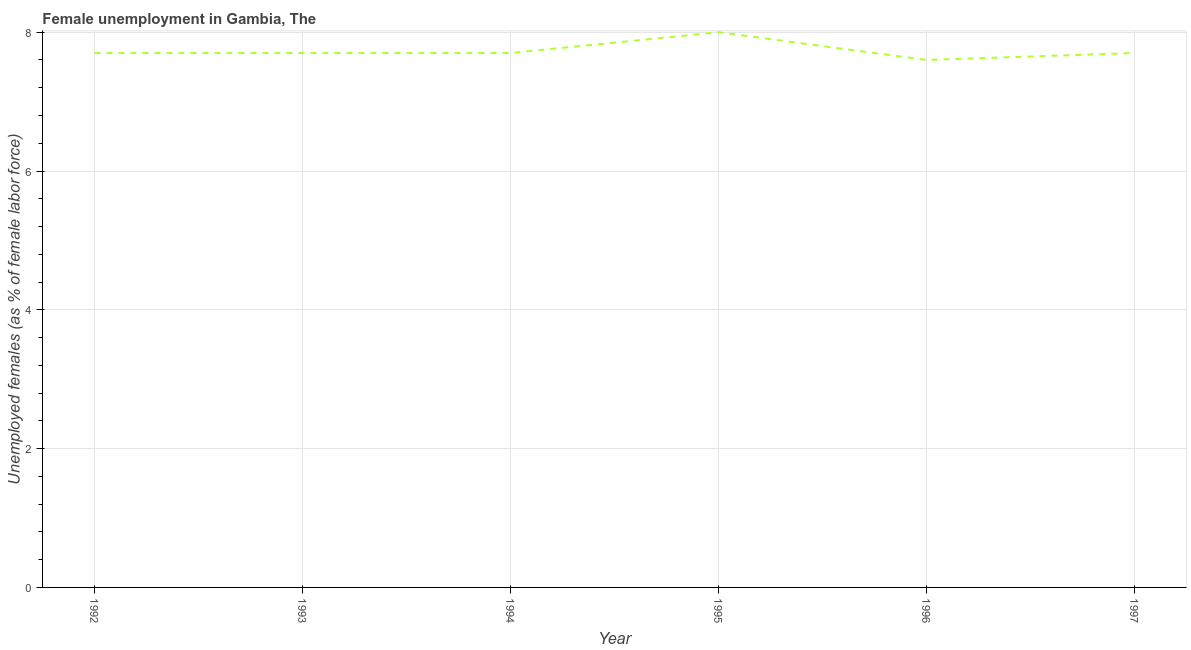What is the unemployed females population in 1995?
Provide a succinct answer. 8. Across all years, what is the maximum unemployed females population?
Your answer should be compact. 8. Across all years, what is the minimum unemployed females population?
Offer a terse response. 7.6. In which year was the unemployed females population maximum?
Make the answer very short. 1995. In which year was the unemployed females population minimum?
Provide a short and direct response. 1996. What is the sum of the unemployed females population?
Provide a succinct answer. 46.4. What is the difference between the unemployed females population in 1994 and 1997?
Offer a very short reply. 0. What is the average unemployed females population per year?
Provide a succinct answer. 7.73. What is the median unemployed females population?
Offer a very short reply. 7.7. Do a majority of the years between 1995 and 1997 (inclusive) have unemployed females population greater than 6 %?
Your answer should be compact. Yes. What is the ratio of the unemployed females population in 1994 to that in 1995?
Give a very brief answer. 0.96. Is the unemployed females population in 1992 less than that in 1993?
Give a very brief answer. No. What is the difference between the highest and the second highest unemployed females population?
Keep it short and to the point. 0.3. Is the sum of the unemployed females population in 1992 and 1996 greater than the maximum unemployed females population across all years?
Offer a terse response. Yes. What is the difference between the highest and the lowest unemployed females population?
Keep it short and to the point. 0.4. Does the unemployed females population monotonically increase over the years?
Give a very brief answer. No. How many lines are there?
Provide a short and direct response. 1. What is the difference between two consecutive major ticks on the Y-axis?
Offer a terse response. 2. Does the graph contain grids?
Give a very brief answer. Yes. What is the title of the graph?
Make the answer very short. Female unemployment in Gambia, The. What is the label or title of the Y-axis?
Provide a short and direct response. Unemployed females (as % of female labor force). What is the Unemployed females (as % of female labor force) in 1992?
Offer a terse response. 7.7. What is the Unemployed females (as % of female labor force) of 1993?
Give a very brief answer. 7.7. What is the Unemployed females (as % of female labor force) of 1994?
Give a very brief answer. 7.7. What is the Unemployed females (as % of female labor force) of 1996?
Ensure brevity in your answer.  7.6. What is the Unemployed females (as % of female labor force) of 1997?
Ensure brevity in your answer.  7.7. What is the difference between the Unemployed females (as % of female labor force) in 1992 and 1993?
Your answer should be very brief. 0. What is the difference between the Unemployed females (as % of female labor force) in 1992 and 1994?
Offer a very short reply. 0. What is the difference between the Unemployed females (as % of female labor force) in 1992 and 1996?
Ensure brevity in your answer.  0.1. What is the difference between the Unemployed females (as % of female labor force) in 1992 and 1997?
Offer a very short reply. 0. What is the difference between the Unemployed females (as % of female labor force) in 1993 and 1994?
Offer a very short reply. 0. What is the difference between the Unemployed females (as % of female labor force) in 1993 and 1996?
Your answer should be compact. 0.1. What is the difference between the Unemployed females (as % of female labor force) in 1993 and 1997?
Your answer should be very brief. 0. What is the difference between the Unemployed females (as % of female labor force) in 1994 and 1995?
Make the answer very short. -0.3. What is the difference between the Unemployed females (as % of female labor force) in 1995 and 1996?
Your answer should be compact. 0.4. What is the difference between the Unemployed females (as % of female labor force) in 1995 and 1997?
Ensure brevity in your answer.  0.3. What is the ratio of the Unemployed females (as % of female labor force) in 1992 to that in 1994?
Offer a terse response. 1. What is the ratio of the Unemployed females (as % of female labor force) in 1992 to that in 1995?
Offer a terse response. 0.96. What is the ratio of the Unemployed females (as % of female labor force) in 1992 to that in 1996?
Your response must be concise. 1.01. What is the ratio of the Unemployed females (as % of female labor force) in 1993 to that in 1997?
Your answer should be compact. 1. What is the ratio of the Unemployed females (as % of female labor force) in 1994 to that in 1995?
Offer a terse response. 0.96. What is the ratio of the Unemployed females (as % of female labor force) in 1995 to that in 1996?
Keep it short and to the point. 1.05. What is the ratio of the Unemployed females (as % of female labor force) in 1995 to that in 1997?
Keep it short and to the point. 1.04. 